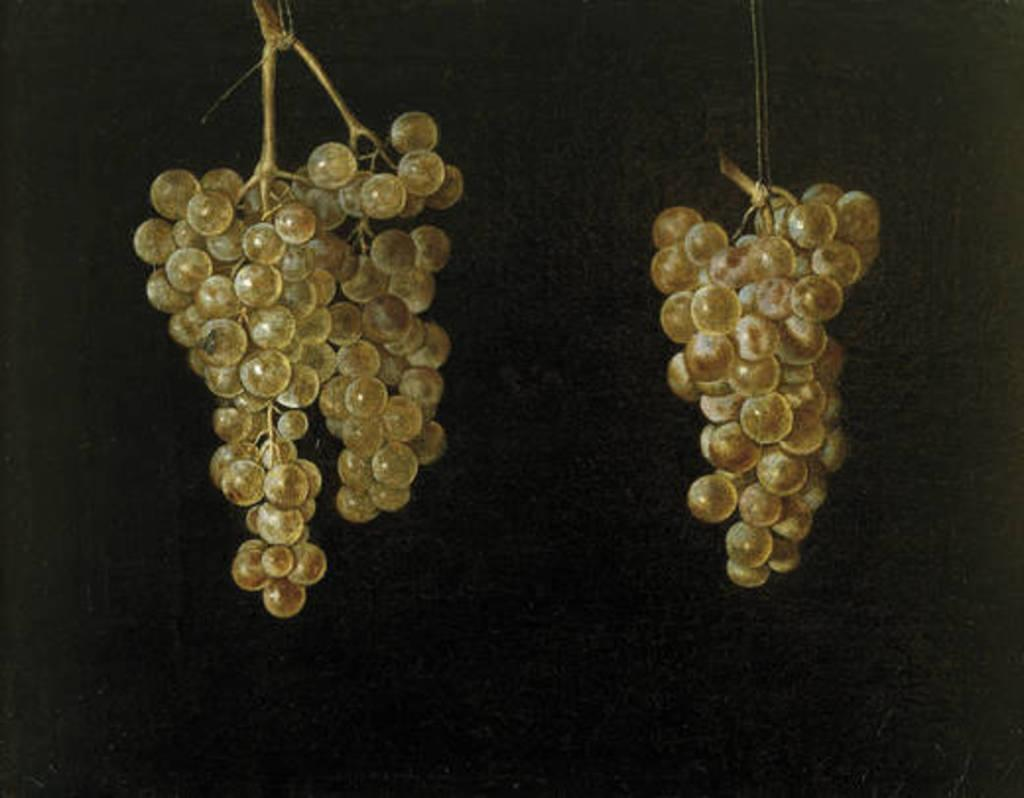What type of fruit is depicted in the image? The image contains artificial grapes. How are the artificial grapes arranged in the image? The artificial grapes are hanging. What can be observed about the lighting in the image? The background of the image is dark. What type of payment is required to access the gun in the image? There is no gun present in the image, so no payment is required. 